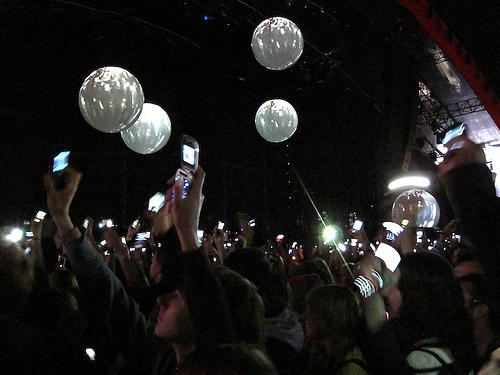Question: how many white globes are in the air?
Choices:
A. 5.
B. 4.
C. 6.
D. 7.
Answer with the letter. Answer: A Question: when was the image taken?
Choices:
A. Night time.
B. After the party.
C. After the police arrived.
D. Before the police arrived.
Answer with the letter. Answer: A Question: what color are the glowing globes?
Choices:
A. Blue.
B. Red.
C. Green.
D. White.
Answer with the letter. Answer: D Question: how many dogs are in the image?
Choices:
A. 2.
B. 0.
C. 1.
D. 3.
Answer with the letter. Answer: B Question: what are the people using to capture photos with?
Choices:
A. An artist.
B. A camera.
C. A video camera.
D. Their phones.
Answer with the letter. Answer: D 